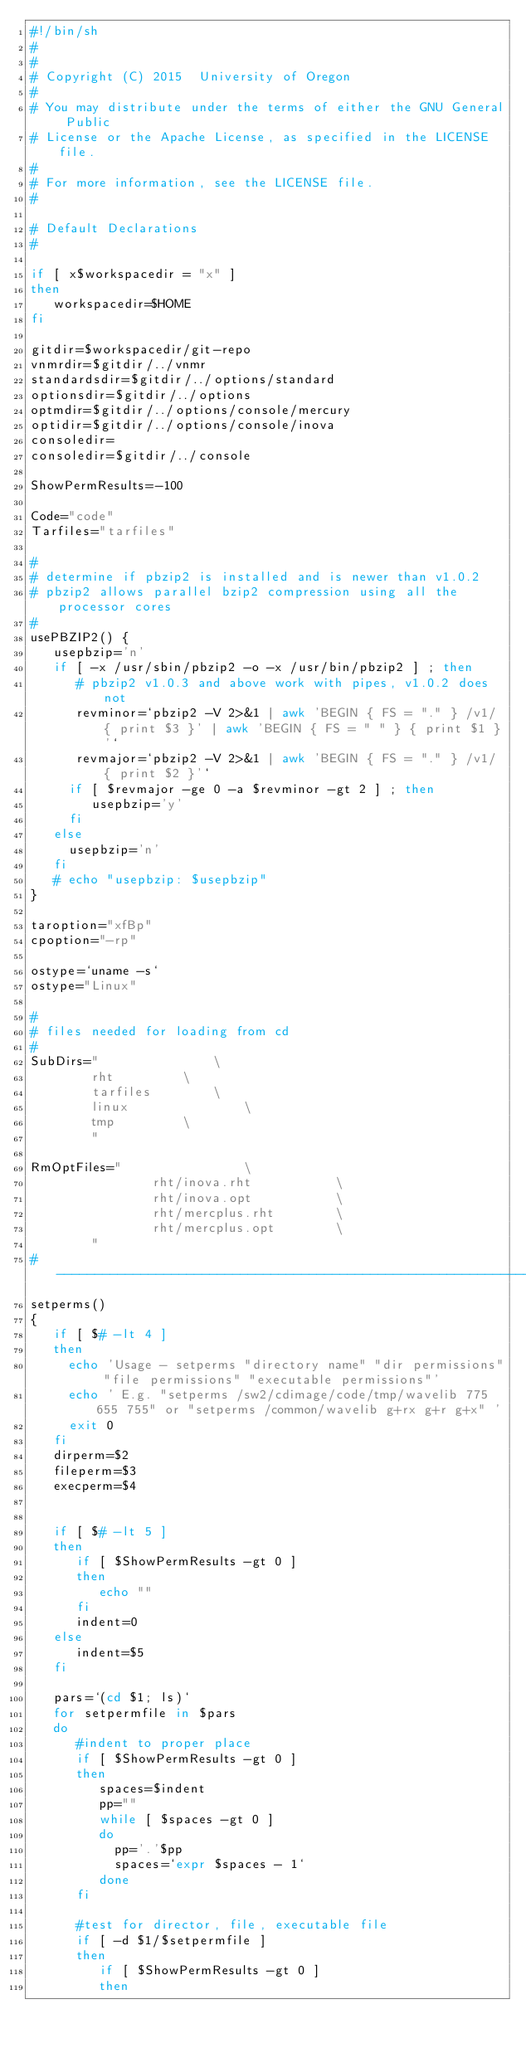Convert code to text. <code><loc_0><loc_0><loc_500><loc_500><_Bash_>#!/bin/sh
#
#
# Copyright (C) 2015  University of Oregon
# 
# You may distribute under the terms of either the GNU General Public
# License or the Apache License, as specified in the LICENSE file.
# 
# For more information, see the LICENSE file.
# 

# Default Declarations
#

if [ x$workspacedir = "x" ]
then
   workspacedir=$HOME
fi

gitdir=$workspacedir/git-repo
vnmrdir=$gitdir/../vnmr
standardsdir=$gitdir/../options/standard
optionsdir=$gitdir/../options
optmdir=$gitdir/../options/console/mercury
optidir=$gitdir/../options/console/inova
consoledir=
consoledir=$gitdir/../console

ShowPermResults=-100

Code="code"
Tarfiles="tarfiles"
 
#
# determine if pbzip2 is installed and is newer than v1.0.2
# pbzip2 allows parallel bzip2 compression using all the processor cores
#
usePBZIP2() {
   usepbzip='n'
   if [ -x /usr/sbin/pbzip2 -o -x /usr/bin/pbzip2 ] ; then
      # pbzip2 v1.0.3 and above work with pipes, v1.0.2 does not 
      revminor=`pbzip2 -V 2>&1 | awk 'BEGIN { FS = "." } /v1/ { print $3 }' | awk 'BEGIN { FS = " " } { print $1 }'`
      revmajor=`pbzip2 -V 2>&1 | awk 'BEGIN { FS = "." } /v1/ { print $2 }'`
     if [ $revmajor -ge 0 -a $revminor -gt 2 ] ; then
        usepbzip='y'
     fi
   else
     usepbzip='n'
   fi
   # echo "usepbzip: $usepbzip"
}

taroption="xfBp"
cpoption="-rp"

ostype=`uname -s`
ostype="Linux"

#
# files needed for loading from cd
#
SubDirs="				\
		rht			\
		tarfiles		\
		linux		        \
		tmp			\
		"

RmOptFiles="				\
                rht/inova.rht           \
                rht/inova.opt           \
                rht/mercplus.rht        \
                rht/mercplus.opt        \
		"
#---------------------------------------------------------------------------
setperms()
{
   if [ $# -lt 4 ]
   then
     echo 'Usage - setperms "directory name" "dir permissions" "file permissions" "executable permissions"'
     echo ' E.g. "setperms /sw2/cdimage/code/tmp/wavelib 775 655 755" or "setperms /common/wavelib g+rx g+r g+x" '
     exit 0
   fi
   dirperm=$2
   fileperm=$3
   execperm=$4
   
   
   if [ $# -lt 5 ]
   then
      if [ $ShowPermResults -gt 0 ]
      then
         echo "" 
      fi
      indent=0
   else
      indent=$5
   fi
   
   pars=`(cd $1; ls)`
   for setpermfile in $pars
   do
      #indent to proper place
      if [ $ShowPermResults -gt 0 ]
      then
         spaces=$indent
         pp=""
         while [ $spaces -gt 0 ]
         do
           pp='.'$pp
           spaces=`expr $spaces - 1`
         done
      fi
   
      #test for director, file, executable file
      if [ -d $1/$setpermfile ]
      then
         if [ $ShowPermResults -gt 0 ]
         then</code> 